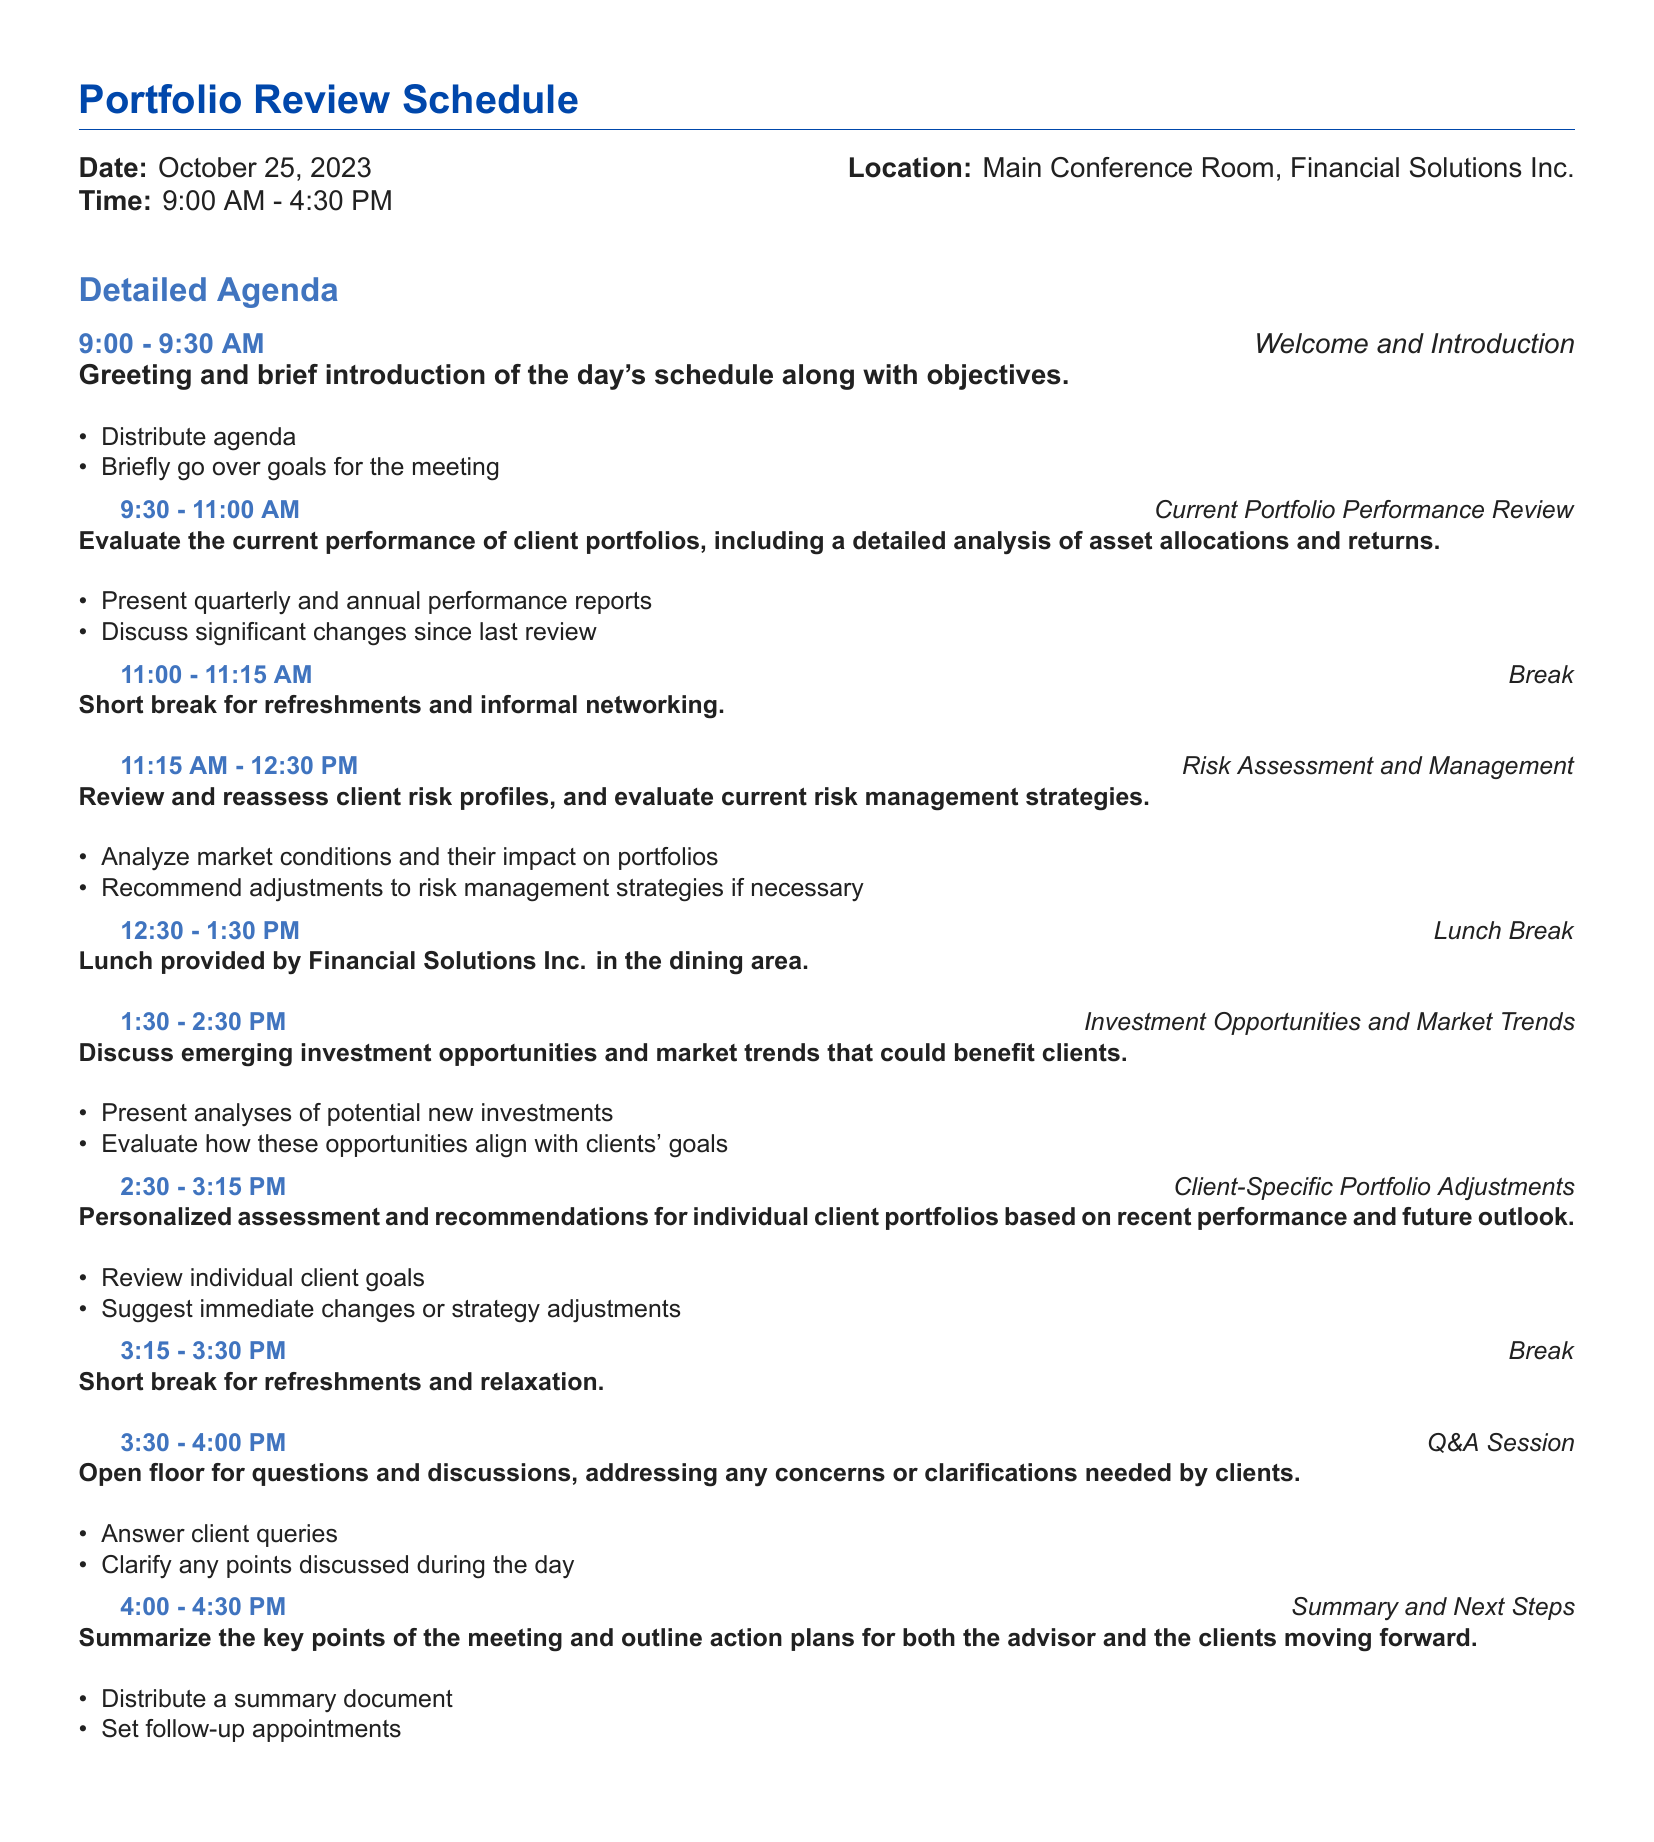What is the date of the Portfolio Review Schedule? The date of the schedule is specifically mentioned in the document.
Answer: October 25, 2023 What is the location of the meeting? The location is stated in the schedule section of the document.
Answer: Main Conference Room, Financial Solutions Inc What time does the meeting start? The starting time is listed at the beginning of the document.
Answer: 9:00 AM How long is the break after the Current Portfolio Performance Review? The break duration is indicated between specific agenda items.
Answer: 15 minutes What is the main topic of the 1:30 PM session? The agenda outlines the session topics and their time slots.
Answer: Investment Opportunities and Market Trends How many action items are mentioned in the Summary and Next Steps? The action items are outlined in the last portion of the agenda.
Answer: Two What is the duration of the Client-Specific Portfolio Adjustments session? The duration is derived from the document's schedule layout.
Answer: 45 minutes What is the color scheme used for the headings in the document? The specific colors for headers and subheaders are defined in the document code.
Answer: RGB values of blue shades What event follows the break at 3:15 PM? The agenda clearly outlines the sequence of events.
Answer: Q&A Session What is the significance of the Welcome and Introduction session at 9:00 AM? The objectives and activities in the introduction session are described in the agenda.
Answer: Greet and establish meeting goals 